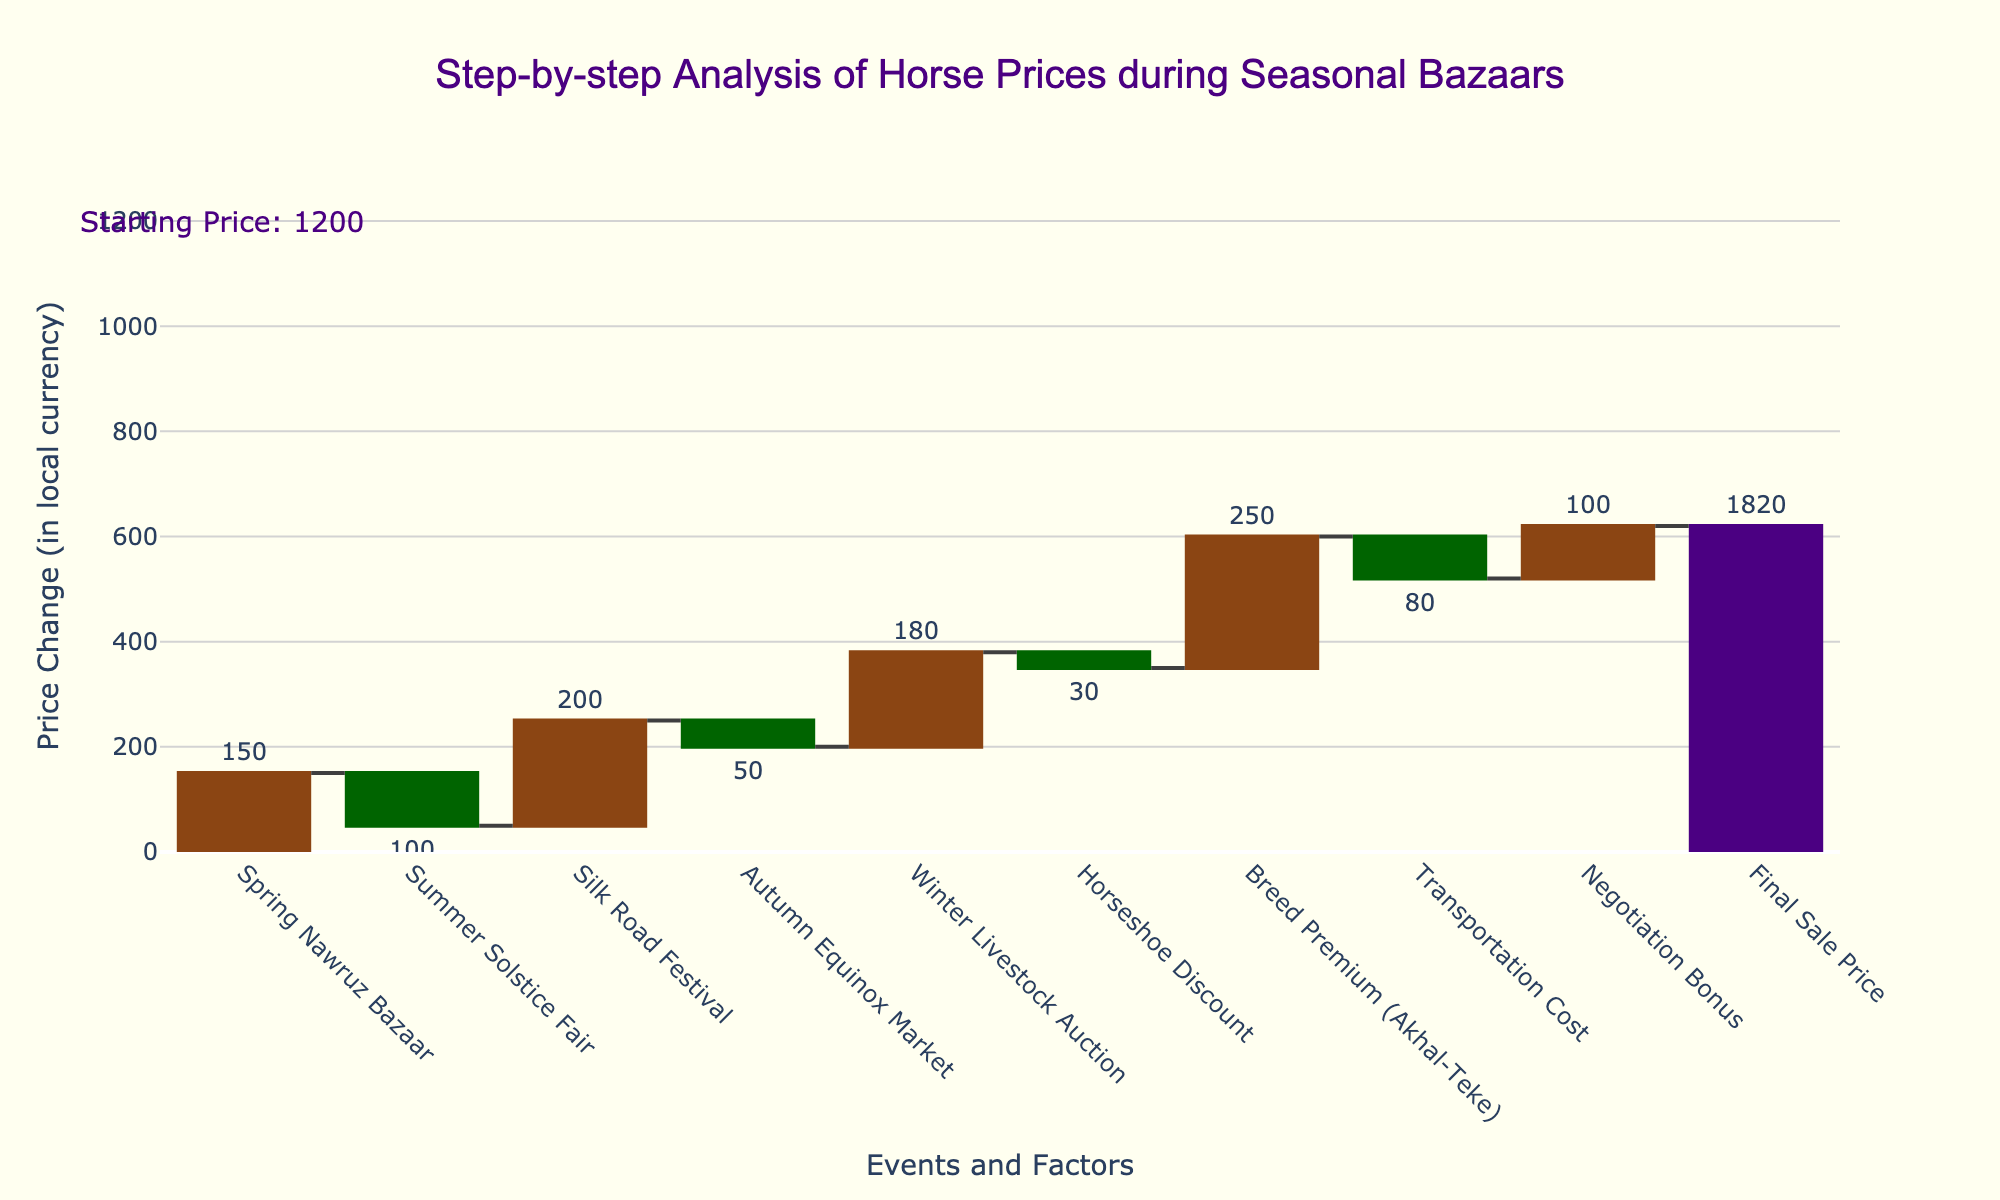What is the starting price of the horse? The starting price is annotated on the left side of the chart with a specific label. The annotation shows "Starting Price: 1200".
Answer: 1200 How much does the horse price increase at the Silk Road Festival? The bar corresponding to the Silk Road Festival is labeled "+200", indicating an increase in horse price by 200.
Answer: 200 What is the title of the chart? The title is prominently displayed at the top of the chart. It reads "Step-by-step Analysis of Horse Prices during Seasonal Bazaars".
Answer: Step-by-step Analysis of Horse Prices during Seasonal Bazaars By how much does the horse price decrease at the summer solstice fair? The bar for the Summer Solstice Fair is labeled "-100", indicating a decrease in the horse price by 100.
Answer: 100 Which event causes the highest increase in horse price? Compare the labels of all positive changes. The Breed Premium (Akhal-Teke) has the highest positive value, labeled "+250".
Answer: Breed Premium (Akhal-Teke) How many events caused a decrease in horse price? Count the bars with negative values. There are two such bars: Summer Solstice Fair (-100) and Autumn Equinox Market (-50).
Answer: 2 What is the final sale price of the horse? The final sale price is shown in the last bar of the waterfall chart, which is labeled "1820".
Answer: 1820 Calculate the net gain or loss from Spring Nawruz Bazaar and Summer Solstice Fair combined. The Spring Nawruz Bazaar increases the price by 150, and the Summer Solstice Fair decreases it by 100. The net change is 150 - 100 = 50.
Answer: 50 Which cost category has the smallest impact on horse price (whether increase or decrease)? Observe the absolute values of all changes. The Horseshoe Discount has the smallest impact with an absolute value of 30.
Answer: Horseshoe Discount What is the overall net change in price due to all the intermediate events (excluding the starting and final prices)? Calculate the sum of all intermediate changes: +150 -100 +200 -50 +180 -30 +250 -80 +100 = +620. The net change is an increase of 620 leading to the final price.
Answer: 620 